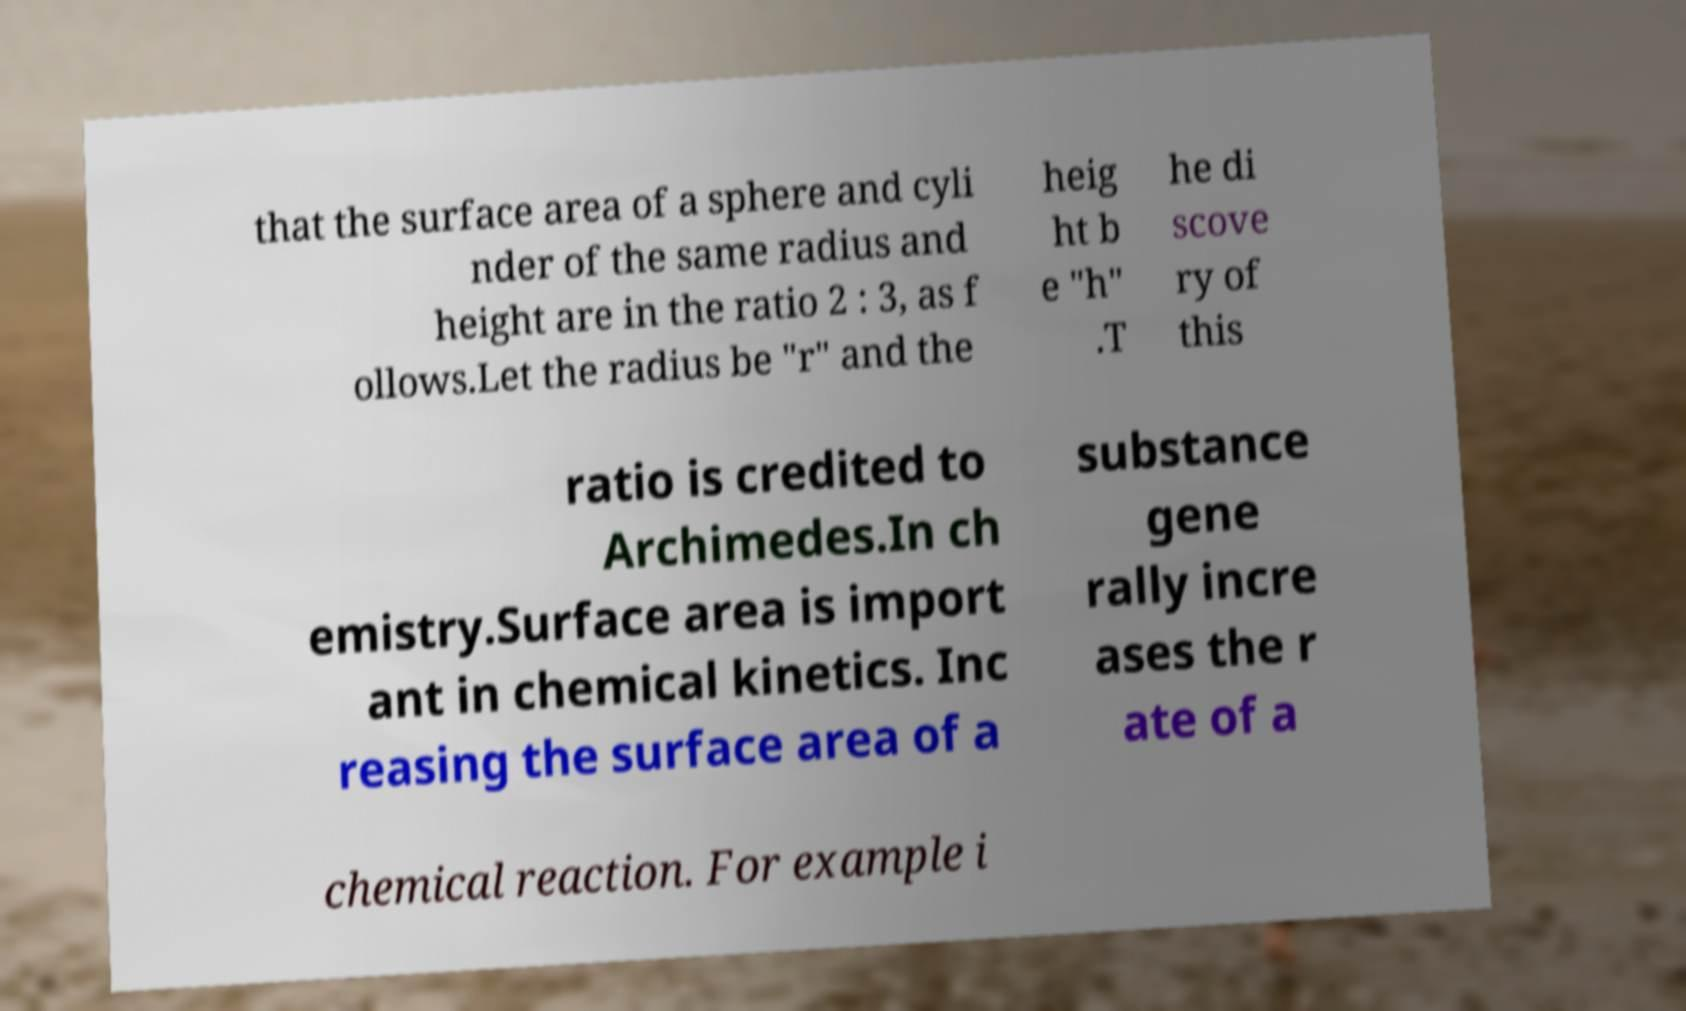Could you extract and type out the text from this image? that the surface area of a sphere and cyli nder of the same radius and height are in the ratio 2 : 3, as f ollows.Let the radius be "r" and the heig ht b e "h" .T he di scove ry of this ratio is credited to Archimedes.In ch emistry.Surface area is import ant in chemical kinetics. Inc reasing the surface area of a substance gene rally incre ases the r ate of a chemical reaction. For example i 